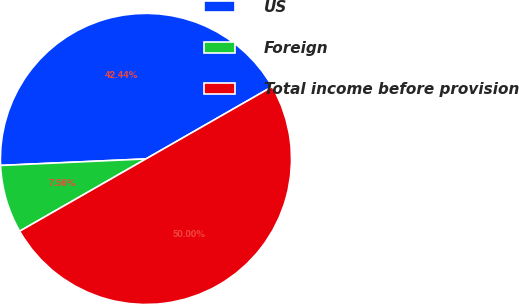Convert chart. <chart><loc_0><loc_0><loc_500><loc_500><pie_chart><fcel>US<fcel>Foreign<fcel>Total income before provision<nl><fcel>42.44%<fcel>7.56%<fcel>50.0%<nl></chart> 